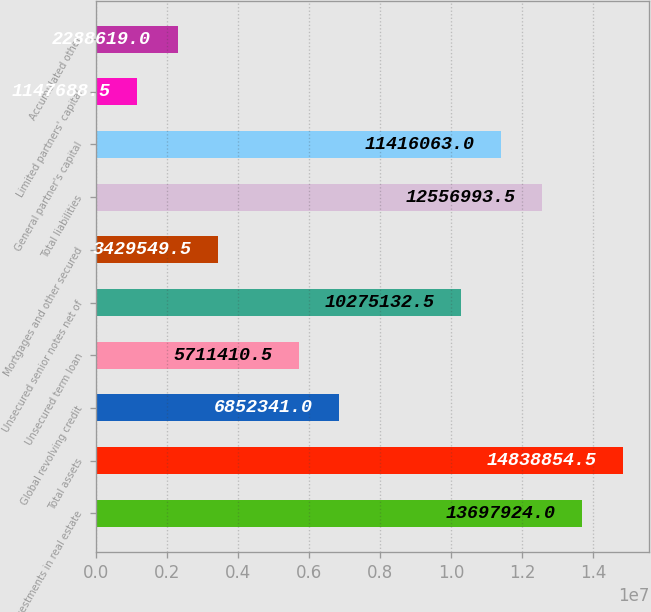Convert chart. <chart><loc_0><loc_0><loc_500><loc_500><bar_chart><fcel>Net investments in real estate<fcel>Total assets<fcel>Global revolving credit<fcel>Unsecured term loan<fcel>Unsecured senior notes net of<fcel>Mortgages and other secured<fcel>Total liabilities<fcel>General partner's capital<fcel>Limited partners' capital<fcel>Accumulated other<nl><fcel>1.36979e+07<fcel>1.48389e+07<fcel>6.85234e+06<fcel>5.71141e+06<fcel>1.02751e+07<fcel>3.42955e+06<fcel>1.2557e+07<fcel>1.14161e+07<fcel>1.14769e+06<fcel>2.28862e+06<nl></chart> 